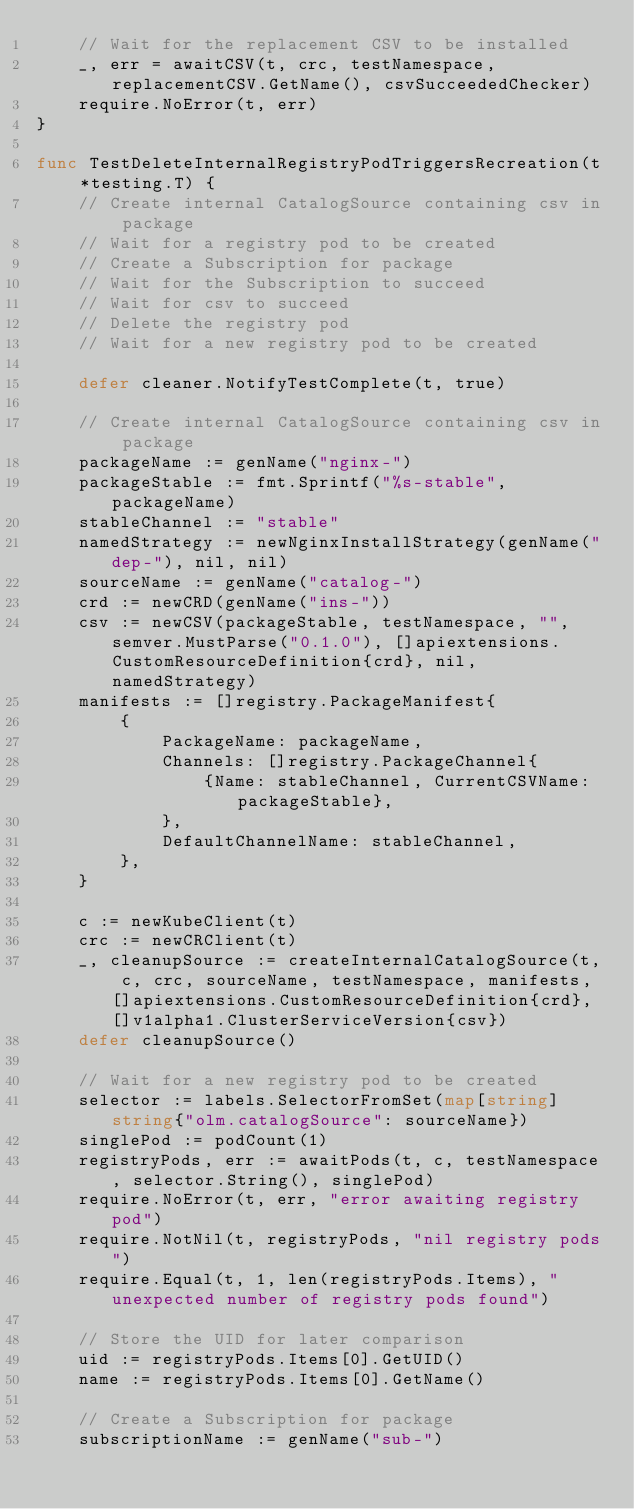<code> <loc_0><loc_0><loc_500><loc_500><_Go_>	// Wait for the replacement CSV to be installed
	_, err = awaitCSV(t, crc, testNamespace, replacementCSV.GetName(), csvSucceededChecker)
	require.NoError(t, err)
}

func TestDeleteInternalRegistryPodTriggersRecreation(t *testing.T) {
	// Create internal CatalogSource containing csv in package
	// Wait for a registry pod to be created
	// Create a Subscription for package
	// Wait for the Subscription to succeed
	// Wait for csv to succeed
	// Delete the registry pod
	// Wait for a new registry pod to be created

	defer cleaner.NotifyTestComplete(t, true)

	// Create internal CatalogSource containing csv in package
	packageName := genName("nginx-")
	packageStable := fmt.Sprintf("%s-stable", packageName)
	stableChannel := "stable"
	namedStrategy := newNginxInstallStrategy(genName("dep-"), nil, nil)
	sourceName := genName("catalog-")
	crd := newCRD(genName("ins-"))
	csv := newCSV(packageStable, testNamespace, "", semver.MustParse("0.1.0"), []apiextensions.CustomResourceDefinition{crd}, nil, namedStrategy)
	manifests := []registry.PackageManifest{
		{
			PackageName: packageName,
			Channels: []registry.PackageChannel{
				{Name: stableChannel, CurrentCSVName: packageStable},
			},
			DefaultChannelName: stableChannel,
		},
	}

	c := newKubeClient(t)
	crc := newCRClient(t)
	_, cleanupSource := createInternalCatalogSource(t, c, crc, sourceName, testNamespace, manifests, []apiextensions.CustomResourceDefinition{crd}, []v1alpha1.ClusterServiceVersion{csv})
	defer cleanupSource()

	// Wait for a new registry pod to be created
	selector := labels.SelectorFromSet(map[string]string{"olm.catalogSource": sourceName})
	singlePod := podCount(1)
	registryPods, err := awaitPods(t, c, testNamespace, selector.String(), singlePod)
	require.NoError(t, err, "error awaiting registry pod")
	require.NotNil(t, registryPods, "nil registry pods")
	require.Equal(t, 1, len(registryPods.Items), "unexpected number of registry pods found")

	// Store the UID for later comparison
	uid := registryPods.Items[0].GetUID()
	name := registryPods.Items[0].GetName()

	// Create a Subscription for package
	subscriptionName := genName("sub-")</code> 